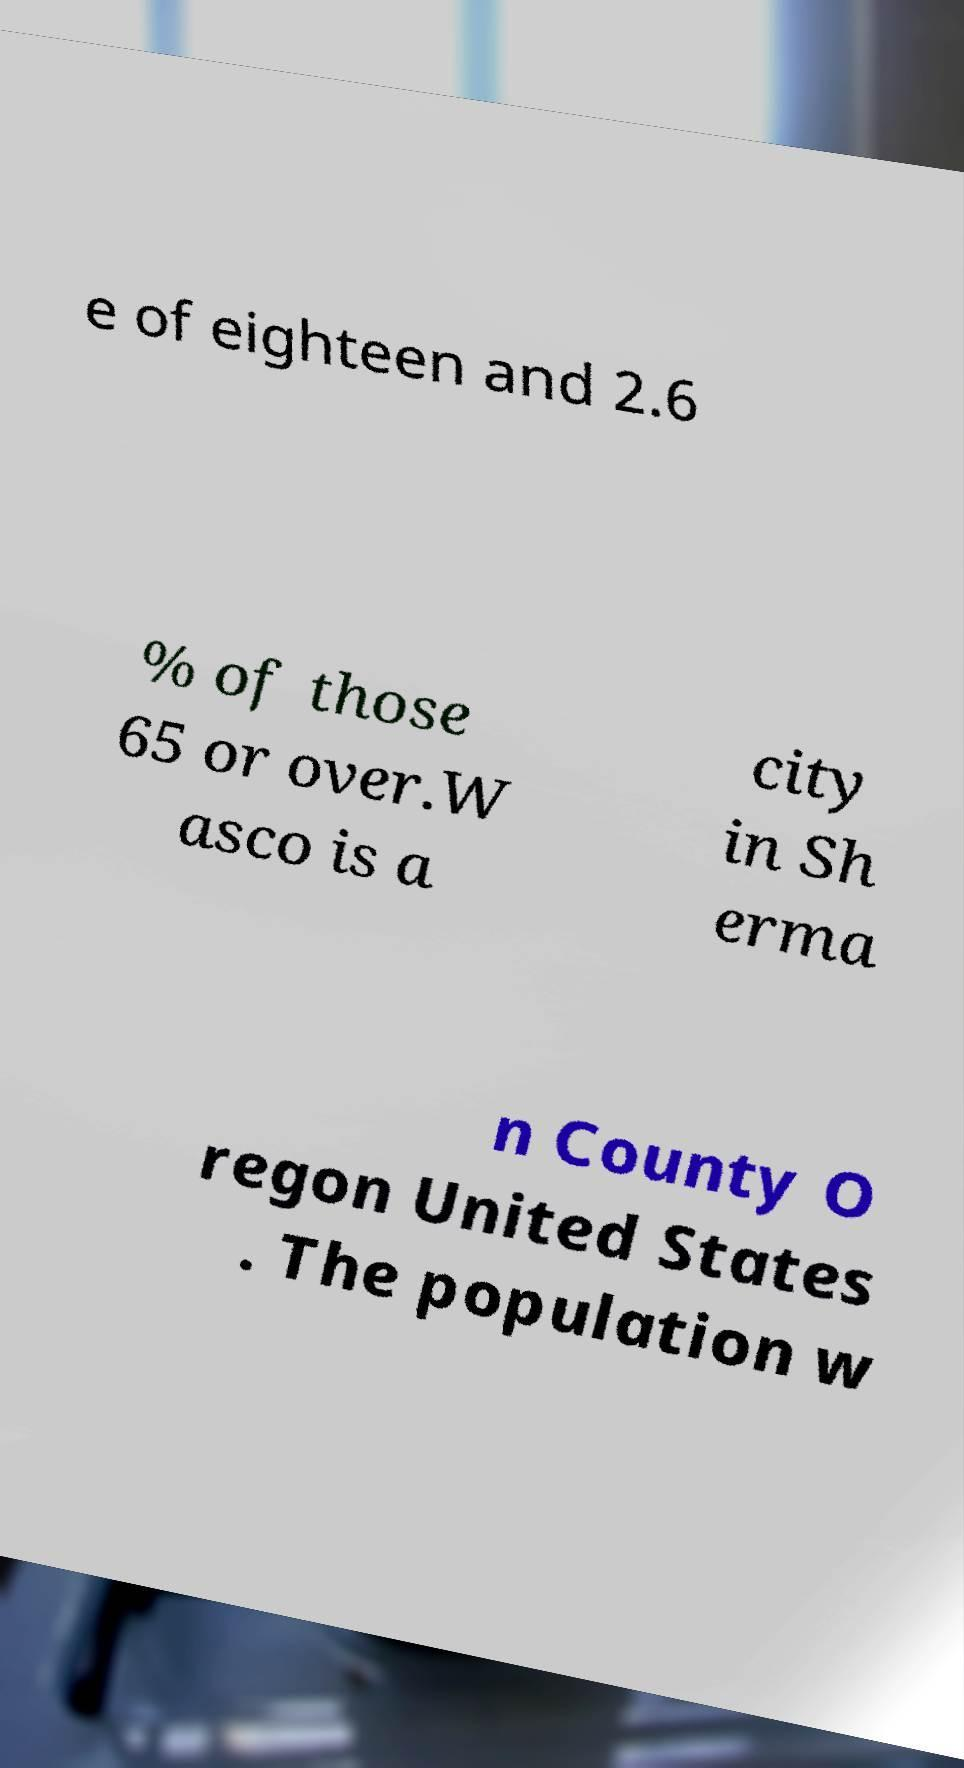Can you accurately transcribe the text from the provided image for me? e of eighteen and 2.6 % of those 65 or over.W asco is a city in Sh erma n County O regon United States . The population w 